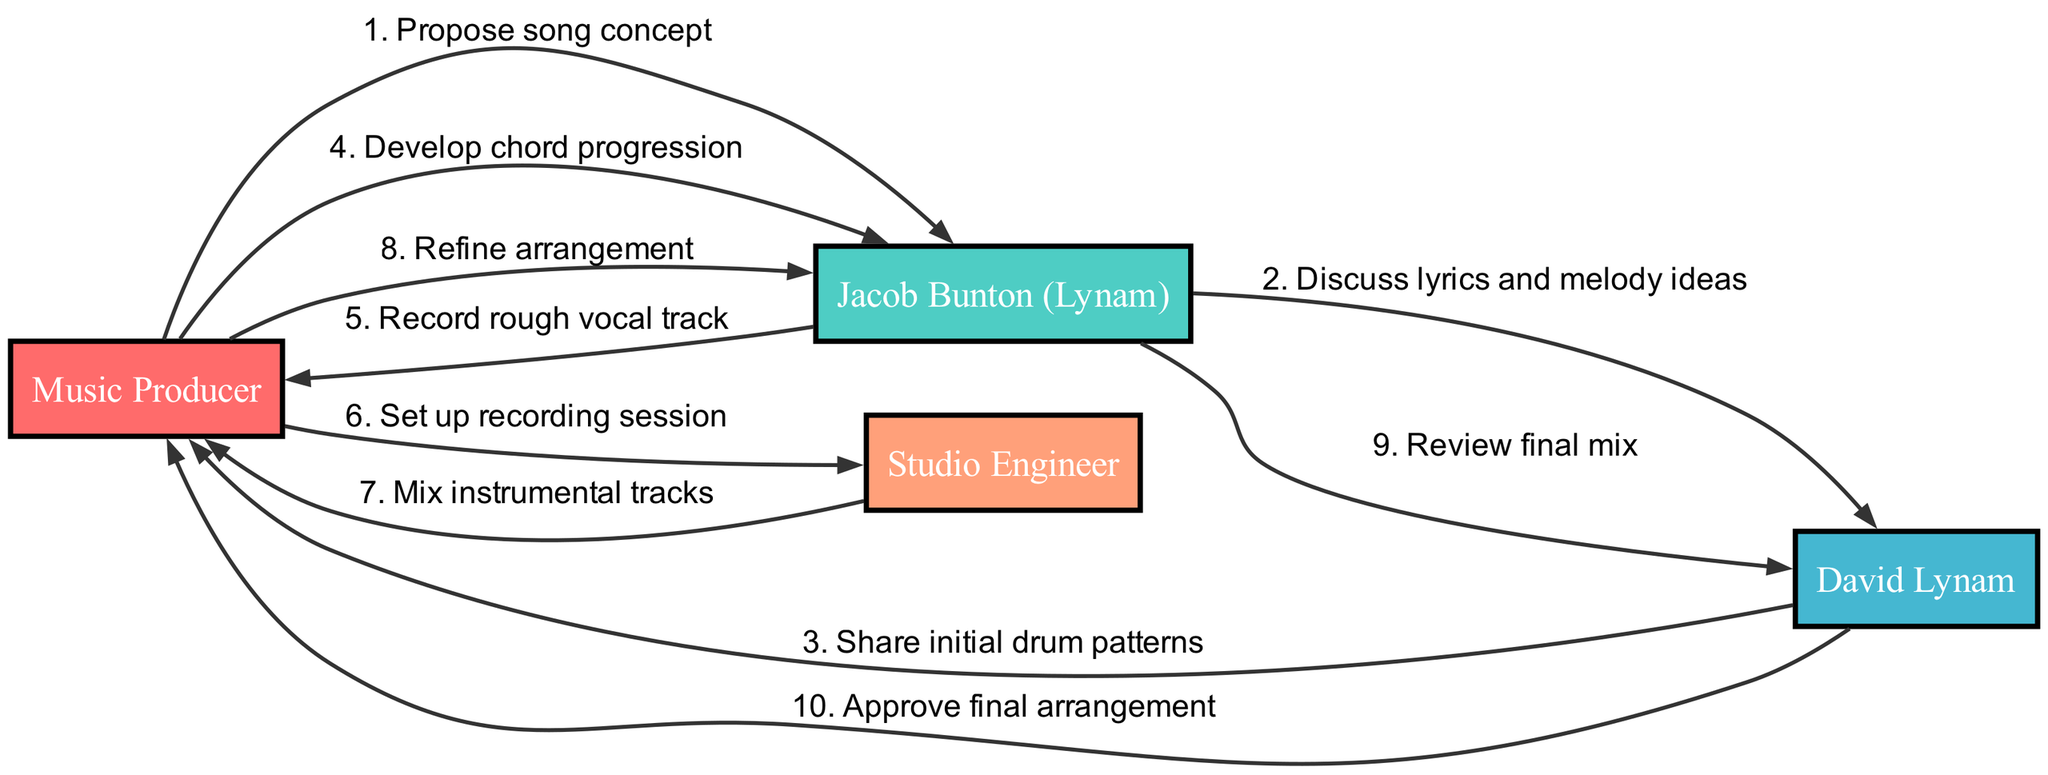What is the first message in the sequence? The first message is sent from the Music Producer to Jacob Bunton, proposing the song concept. Therefore, the answer reflects that initial communication.
Answer: Propose song concept How many actors are involved in the collaborative songwriting process? There are a total of four actors: Music Producer, Jacob Bunton (Lynam), David Lynam, and Studio Engineer, making the count straightforward based on the actor nodes.
Answer: Four Who is responsible for recording the rough vocal track? The diagram indicates that Jacob Bunton is the one who records the rough vocal track during the process, as shown by the direct message from Jacob to the Music Producer.
Answer: Jacob Bunton (Lynam) What is the last message in the sequence? The last message is sent from David Lynam to the Music Producer, where he approves the final arrangement, closing the sequence efficiently.
Answer: Approve final arrangement Which actor receives the initial drum patterns? The initial drum patterns are shared by David Lynam with the Music Producer, as indicated by the directed flow of that particular message in the sequence.
Answer: Music Producer What message follows the development of the chord progression? The message that follows is from Jacob Bunton, who records the rough vocal track, reflecting a progression of the songwriting tasks after chord development.
Answer: Record rough vocal track How many messages are exchanged between Jacob Bunton and David Lynam? The sequence shows that there are two messages exchanged between Jacob Bunton and David Lynam, as they discuss lyrics and melody ideas, and later review the final mix.
Answer: Two Which actor sets up the recording session? The Music Producer is responsible for setting up the recording session, as shown by the directed message to the Studio Engineer asking for this setup.
Answer: Music Producer What is the relationship between the Music Producer and the Studio Engineer? The Music Producer delegates the task of setting up the recording session to the Studio Engineer, indicating a collaborative relationship where the Producer relies on the Engineer’s expertise.
Answer: Delegation 